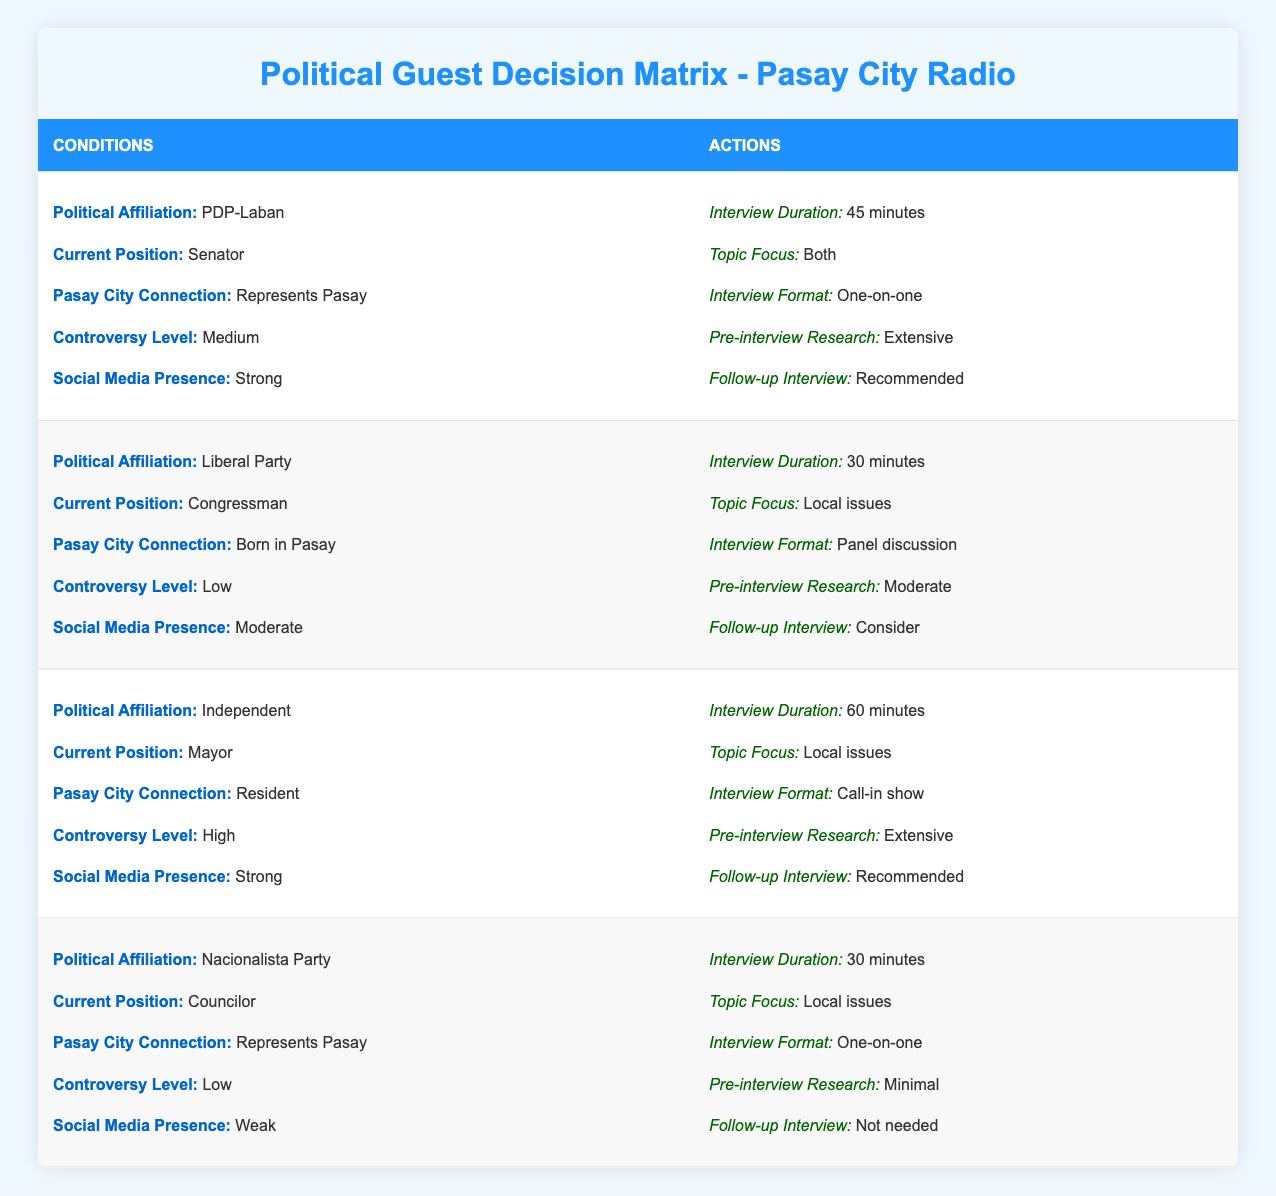What is the recommended interview duration for a PDP-Laban senator who represents Pasay? The table states that for a PDP-Laban senator who represents Pasay, the recommended interview duration is 45 minutes.
Answer: 45 minutes What political affiliation does the Congressman who was born in Pasay belong to? The table indicates that the Congressman born in Pasay is affiliated with the Liberal Party.
Answer: Liberal Party How many guests in the table have a strong social media presence? There are two guests with a strong social media presence: the Independent Mayor and the PDP-Laban Senator, so the total number is 2.
Answer: 2 Is it true that a Nacionalista Party Councilor has a high controversy level? The table shows that the Nacionalista Party Councilor has a low controversy level, therefore the statement is false.
Answer: No What is the average interview duration recommended for all guests listed in the table? The interview durations for the four guests are 45 minutes, 30 minutes, 60 minutes, and 30 minutes. The sum is 165 minutes, and divided by 4 gives an average of 41.25 minutes.
Answer: 41.25 minutes For a Mayor with a high controversy level, what is the interview format suggested? According to the table, the suggested interview format for a Mayor with a high controversy level is a call-in show.
Answer: Call-in show Do both interview recommendations for the PDP-Laban Senator and Nacionalista Party Councilor focus on local issues? The PDP-Laban Senator's topic focus is both local and national issues, while the Nacionalista Party Councilor's focus is on local issues only. Thus, the answer is no; they do not both focus on local issues.
Answer: No What is the follow-up interview recommendation for the Liberal Party Congressman? The table indicates that the recommended follow-up interview for the Liberal Party Congressman is to consider it.
Answer: Consider What are the different interview formats recommended for guests with a low controversy level? The table suggests different formats: the Liberal Party Congressman has a panel discussion format, while the Nacionalista Party Councilor has a one-on-one format, indicating there are two different formats for low controversy levels.
Answer: Two formats 